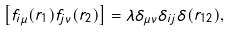Convert formula to latex. <formula><loc_0><loc_0><loc_500><loc_500>\left [ f _ { i \mu } ( { r } _ { 1 } ) f _ { j \nu } ( { r } _ { 2 } ) \right ] = \lambda \delta _ { \mu \nu } \delta _ { i j } \delta ( { r } _ { 1 2 } ) ,</formula> 